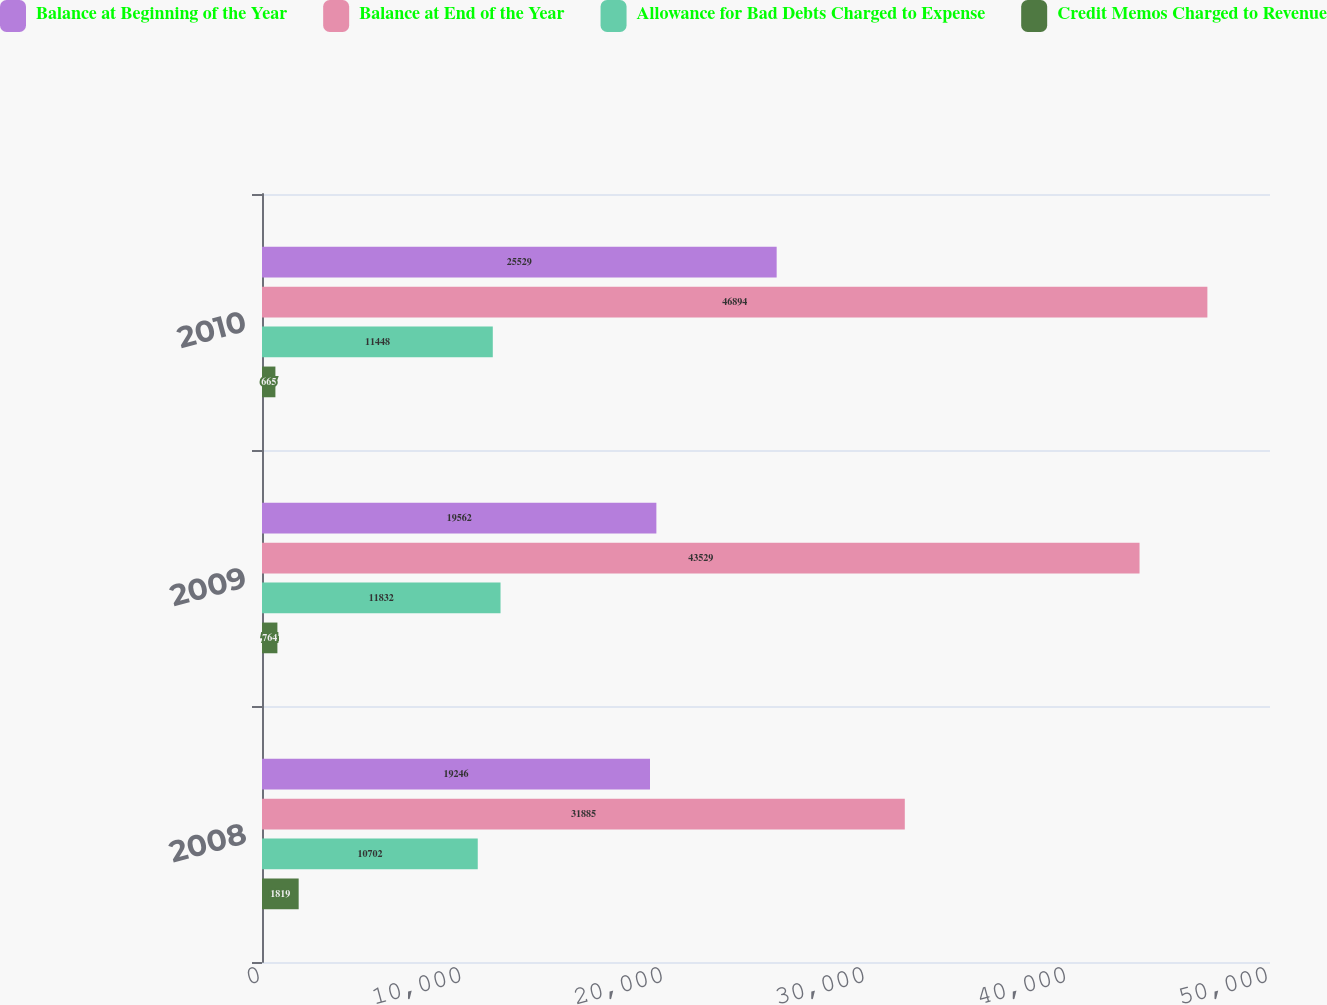Convert chart. <chart><loc_0><loc_0><loc_500><loc_500><stacked_bar_chart><ecel><fcel>2008<fcel>2009<fcel>2010<nl><fcel>Balance at Beginning of the Year<fcel>19246<fcel>19562<fcel>25529<nl><fcel>Balance at End of the Year<fcel>31885<fcel>43529<fcel>46894<nl><fcel>Allowance for Bad Debts Charged to Expense<fcel>10702<fcel>11832<fcel>11448<nl><fcel>Credit Memos Charged to Revenue<fcel>1819<fcel>764<fcel>665<nl></chart> 